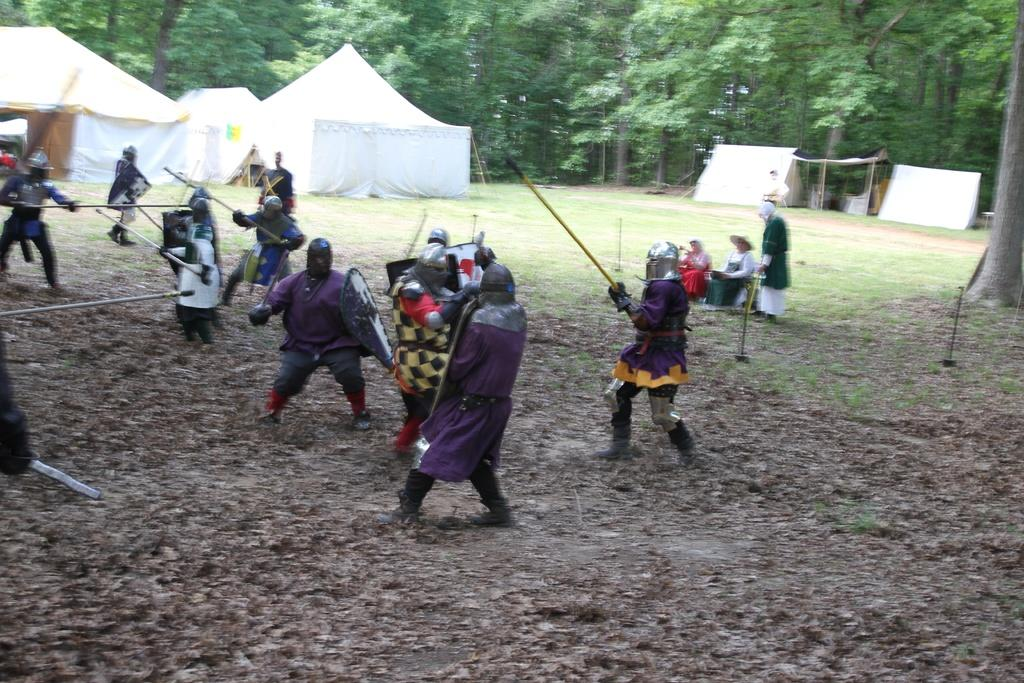What are the people in the image wearing? The people in the image are wearing warrior costumes. What are the people holding in their hands? The people are holding sticks. How many people are sitting in the image? There are two persons sitting in the image. What can be seen in the background of the image? There are tents and trees in the background of the image. What type of toys are the people playing with in the image? There are no toys present in the image; the people are holding sticks. What color is the powder that the people are throwing in the air in the image? There is no powder being thrown in the air in the image. 